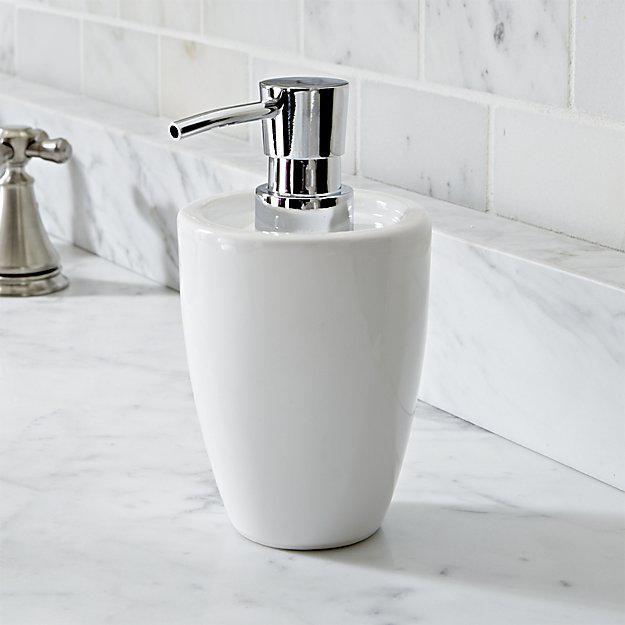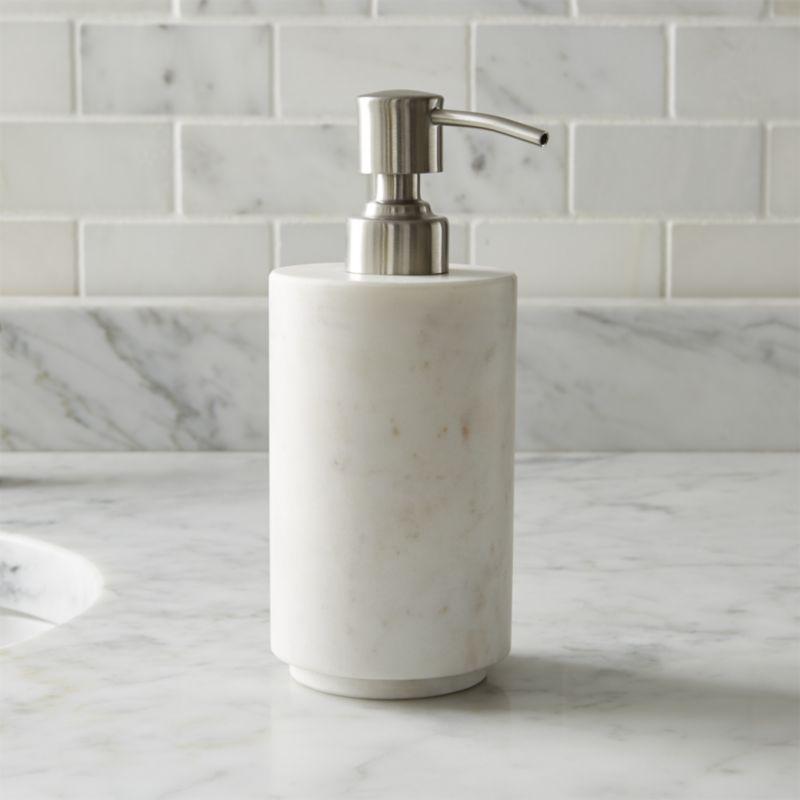The first image is the image on the left, the second image is the image on the right. Assess this claim about the two images: "The left and right image contains the same number of soap dispenser that sit on the sink.". Correct or not? Answer yes or no. Yes. The first image is the image on the left, the second image is the image on the right. Considering the images on both sides, is "There is a clear dispenser with white lotion in it." valid? Answer yes or no. No. 